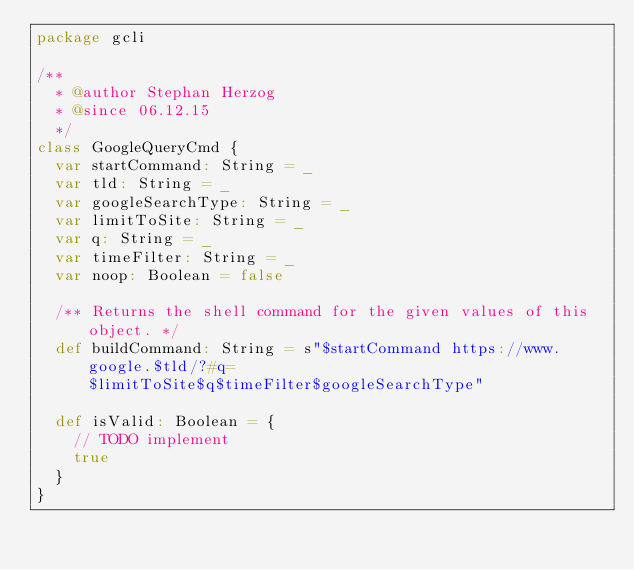<code> <loc_0><loc_0><loc_500><loc_500><_Scala_>package gcli

/**
  * @author Stephan Herzog
  * @since 06.12.15
  */
class GoogleQueryCmd {
  var startCommand: String = _
  var tld: String = _
  var googleSearchType: String = _
  var limitToSite: String = _
  var q: String = _
  var timeFilter: String = _
  var noop: Boolean = false

  /** Returns the shell command for the given values of this object. */
  def buildCommand: String = s"$startCommand https://www.google.$tld/?#q=$limitToSite$q$timeFilter$googleSearchType"

  def isValid: Boolean = {
    // TODO implement
    true
  }
}
</code> 